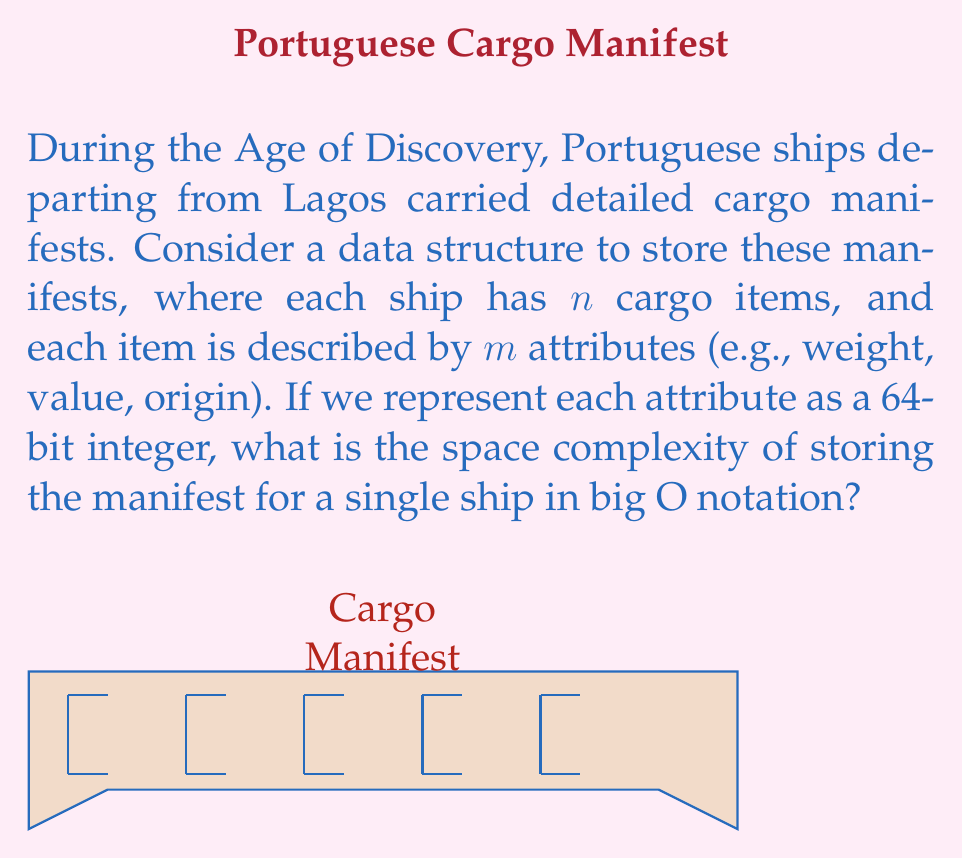Give your solution to this math problem. To determine the space complexity, let's break down the problem step-by-step:

1) For each cargo item, we store $m$ attributes.

2) Each attribute is represented as a 64-bit integer, which occupies a constant amount of space. Let's call this constant $c$.

3) The space required for one cargo item is thus $m \cdot c$.

4) There are $n$ cargo items in total for the ship.

5) Therefore, the total space required is:

   $$ \text{Total Space} = n \cdot (m \cdot c) = c \cdot n \cdot m $$

6) In big O notation, we drop constant factors. The constant $c$ can be omitted.

7) The space complexity is thus $O(nm)$.

This representation allows for efficient storage of cargo manifests, which would have been crucial for Portuguese explorers departing from Lagos during the Age of Discovery, ensuring accurate records of goods transported across the seas.
Answer: $O(nm)$ 